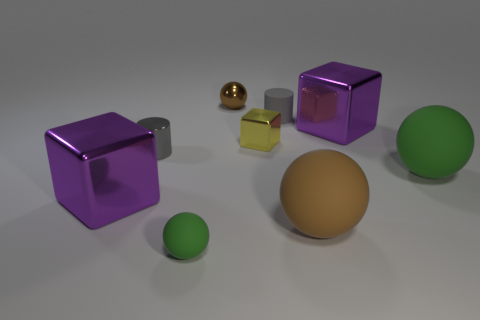Subtract all large green balls. How many balls are left? 3 Subtract 1 cubes. How many cubes are left? 2 Add 1 small brown metallic things. How many objects exist? 10 Subtract all yellow balls. Subtract all blue blocks. How many balls are left? 4 Subtract all spheres. How many objects are left? 5 Subtract 0 purple spheres. How many objects are left? 9 Subtract all small red metallic spheres. Subtract all tiny gray shiny cylinders. How many objects are left? 8 Add 5 tiny metallic cubes. How many tiny metallic cubes are left? 6 Add 6 purple metal blocks. How many purple metal blocks exist? 8 